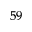Convert formula to latex. <formula><loc_0><loc_0><loc_500><loc_500>^ { 5 9 }</formula> 